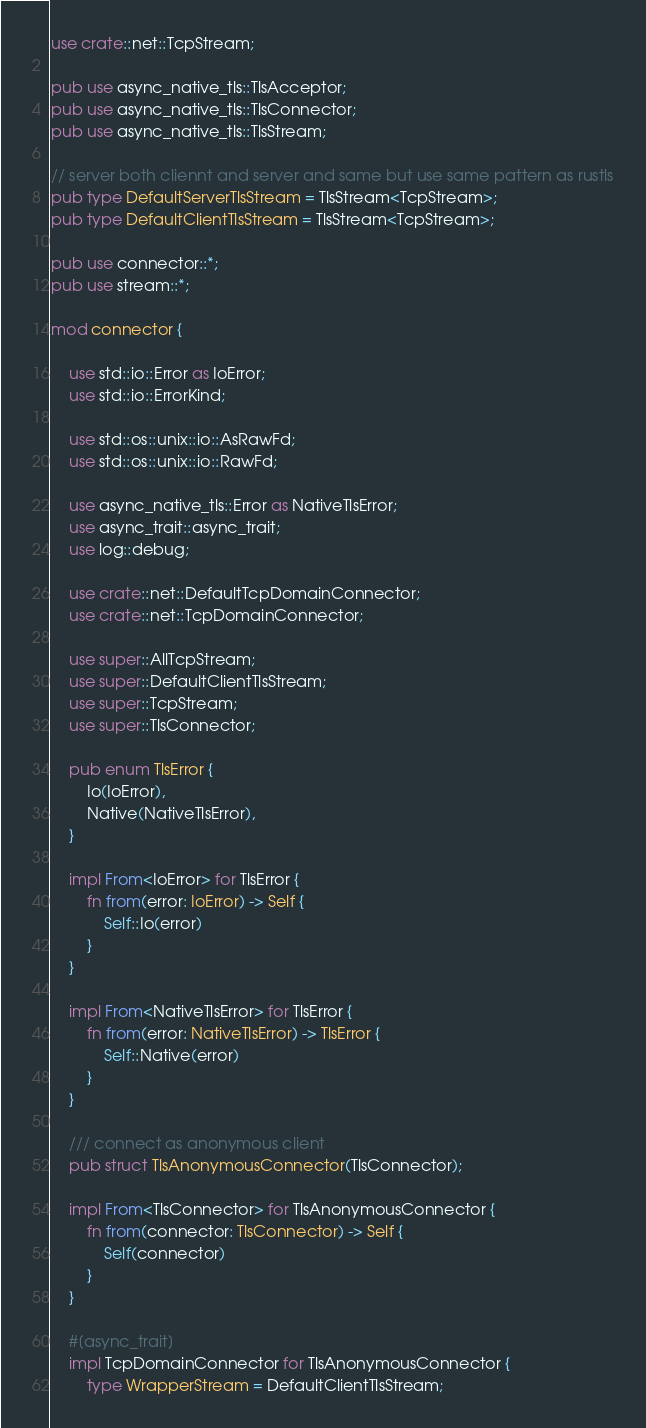Convert code to text. <code><loc_0><loc_0><loc_500><loc_500><_Rust_>use crate::net::TcpStream;

pub use async_native_tls::TlsAcceptor;
pub use async_native_tls::TlsConnector;
pub use async_native_tls::TlsStream;

// server both cliennt and server and same but use same pattern as rustls
pub type DefaultServerTlsStream = TlsStream<TcpStream>;
pub type DefaultClientTlsStream = TlsStream<TcpStream>;

pub use connector::*;
pub use stream::*;

mod connector {

    use std::io::Error as IoError;
    use std::io::ErrorKind;

    use std::os::unix::io::AsRawFd;
    use std::os::unix::io::RawFd;

    use async_native_tls::Error as NativeTlsError;
    use async_trait::async_trait;
    use log::debug;

    use crate::net::DefaultTcpDomainConnector;
    use crate::net::TcpDomainConnector;

    use super::AllTcpStream;
    use super::DefaultClientTlsStream;
    use super::TcpStream;
    use super::TlsConnector;

    pub enum TlsError {
        Io(IoError),
        Native(NativeTlsError),
    }

    impl From<IoError> for TlsError {
        fn from(error: IoError) -> Self {
            Self::Io(error)
        }
    }

    impl From<NativeTlsError> for TlsError {
        fn from(error: NativeTlsError) -> TlsError {
            Self::Native(error)
        }
    }

    /// connect as anonymous client
    pub struct TlsAnonymousConnector(TlsConnector);

    impl From<TlsConnector> for TlsAnonymousConnector {
        fn from(connector: TlsConnector) -> Self {
            Self(connector)
        }
    }

    #[async_trait]
    impl TcpDomainConnector for TlsAnonymousConnector {
        type WrapperStream = DefaultClientTlsStream;
</code> 